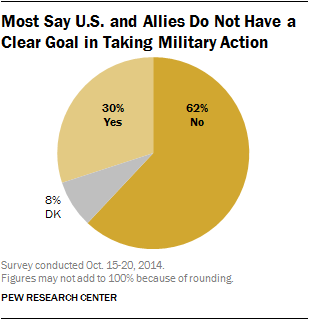Draw attention to some important aspects in this diagram. The value of "No more" is less than the sum of "Yes" and "Dk". The pie graph shows that 8% of the data points fall into the category represented by the color gray. 